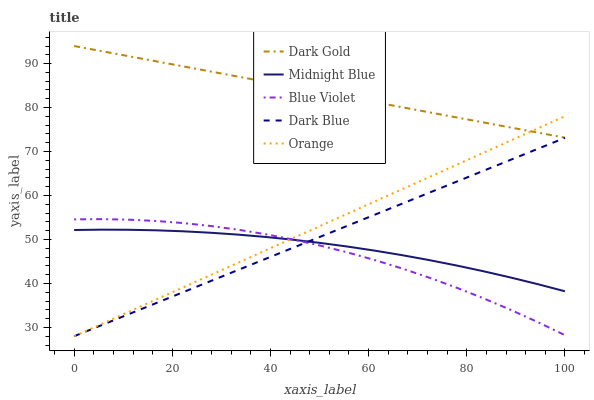Does Blue Violet have the minimum area under the curve?
Answer yes or no. Yes. Does Dark Gold have the maximum area under the curve?
Answer yes or no. Yes. Does Dark Blue have the minimum area under the curve?
Answer yes or no. No. Does Dark Blue have the maximum area under the curve?
Answer yes or no. No. Is Orange the smoothest?
Answer yes or no. Yes. Is Blue Violet the roughest?
Answer yes or no. Yes. Is Dark Blue the smoothest?
Answer yes or no. No. Is Dark Blue the roughest?
Answer yes or no. No. Does Orange have the lowest value?
Answer yes or no. Yes. Does Midnight Blue have the lowest value?
Answer yes or no. No. Does Dark Gold have the highest value?
Answer yes or no. Yes. Does Dark Blue have the highest value?
Answer yes or no. No. Is Blue Violet less than Dark Gold?
Answer yes or no. Yes. Is Dark Gold greater than Midnight Blue?
Answer yes or no. Yes. Does Midnight Blue intersect Blue Violet?
Answer yes or no. Yes. Is Midnight Blue less than Blue Violet?
Answer yes or no. No. Is Midnight Blue greater than Blue Violet?
Answer yes or no. No. Does Blue Violet intersect Dark Gold?
Answer yes or no. No. 